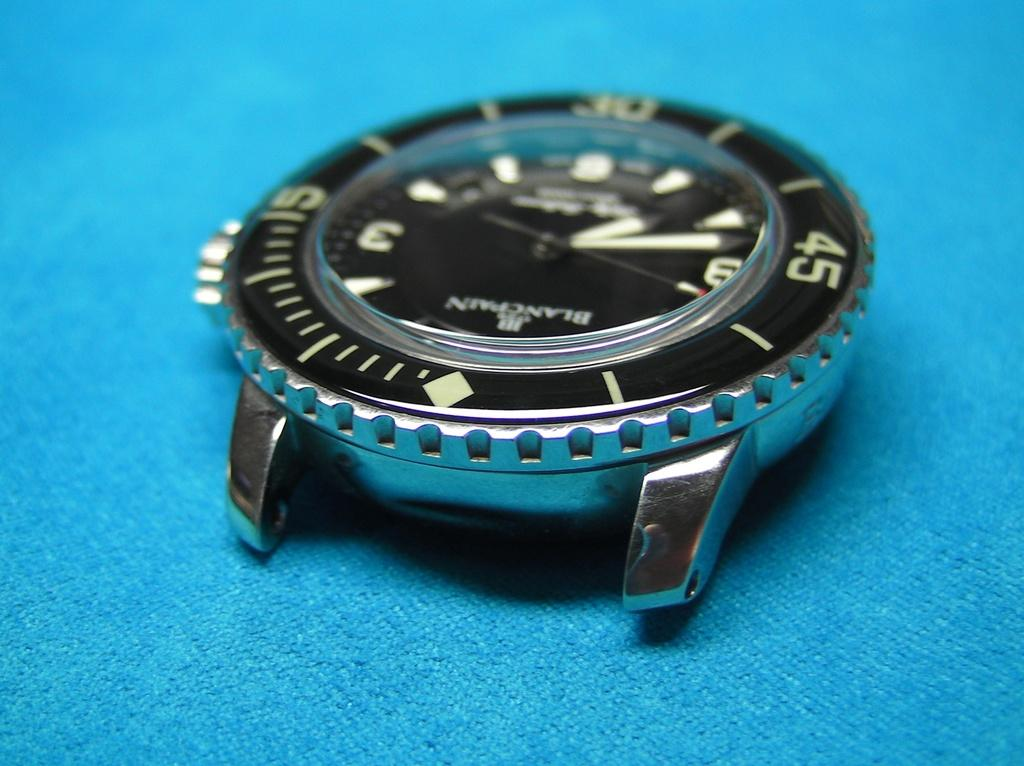<image>
Summarize the visual content of the image. A watch has the name Blancpain written at the top of the dial. 